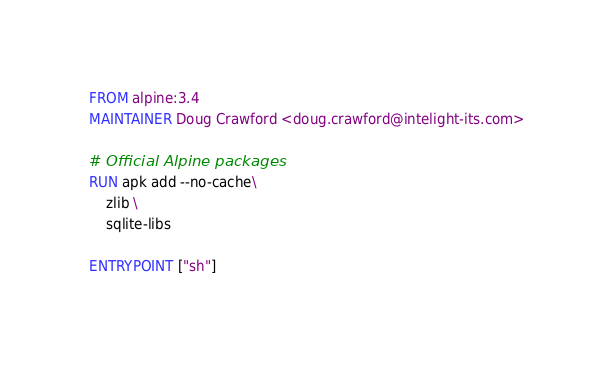<code> <loc_0><loc_0><loc_500><loc_500><_Dockerfile_>FROM alpine:3.4
MAINTAINER Doug Crawford <doug.crawford@intelight-its.com>

# Official Alpine packages
RUN apk add --no-cache\
	zlib \
	sqlite-libs

ENTRYPOINT ["sh"]

</code> 